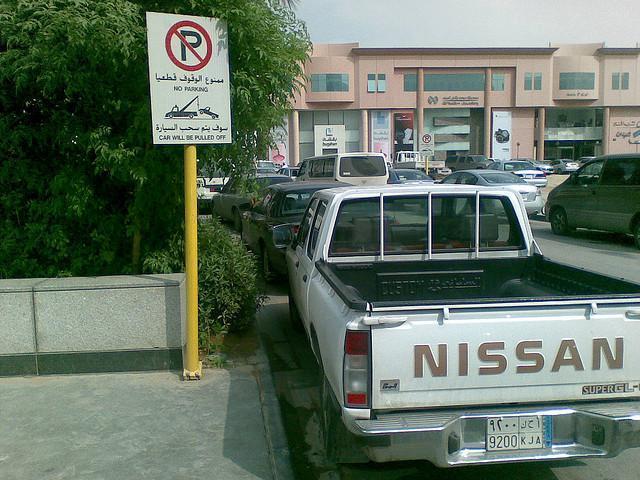How many cars can be seen?
Give a very brief answer. 4. How many cows can be seen?
Give a very brief answer. 0. 